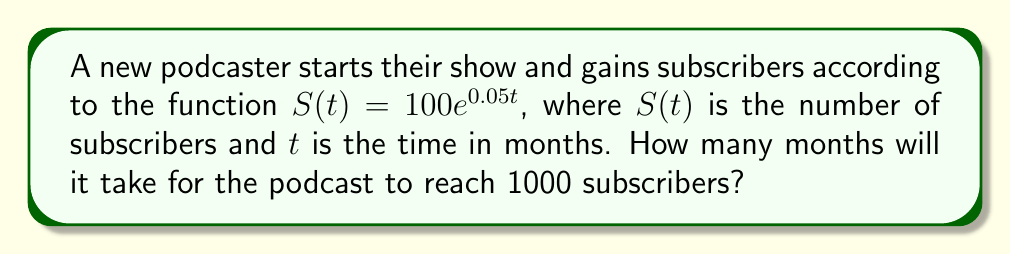Show me your answer to this math problem. To solve this problem, we need to use the given exponential function and solve for $t$ when $S(t) = 1000$. Let's break it down step-by-step:

1) We start with the equation: $S(t) = 100e^{0.05t}$

2) We want to find $t$ when $S(t) = 1000$, so we set up the equation:
   $1000 = 100e^{0.05t}$

3) Divide both sides by 100:
   $10 = e^{0.05t}$

4) Take the natural logarithm of both sides:
   $\ln(10) = \ln(e^{0.05t})$

5) Using the property of logarithms, $\ln(e^x) = x$, we get:
   $\ln(10) = 0.05t$

6) Solve for $t$ by dividing both sides by 0.05:
   $t = \frac{\ln(10)}{0.05}$

7) Calculate the value:
   $t = \frac{2.30259}{0.05} \approx 46.0518$

8) Since we're dealing with months, we round up to the nearest whole number.

Therefore, it will take 47 months for the podcast to reach 1000 subscribers.
Answer: 47 months 